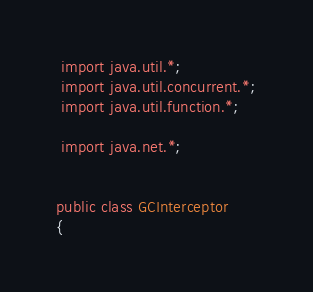<code> <loc_0><loc_0><loc_500><loc_500><_Java_> import java.util.*;
 import java.util.concurrent.*;
 import java.util.function.*;
 
 import java.net.*;


public class GCInterceptor
{</code> 